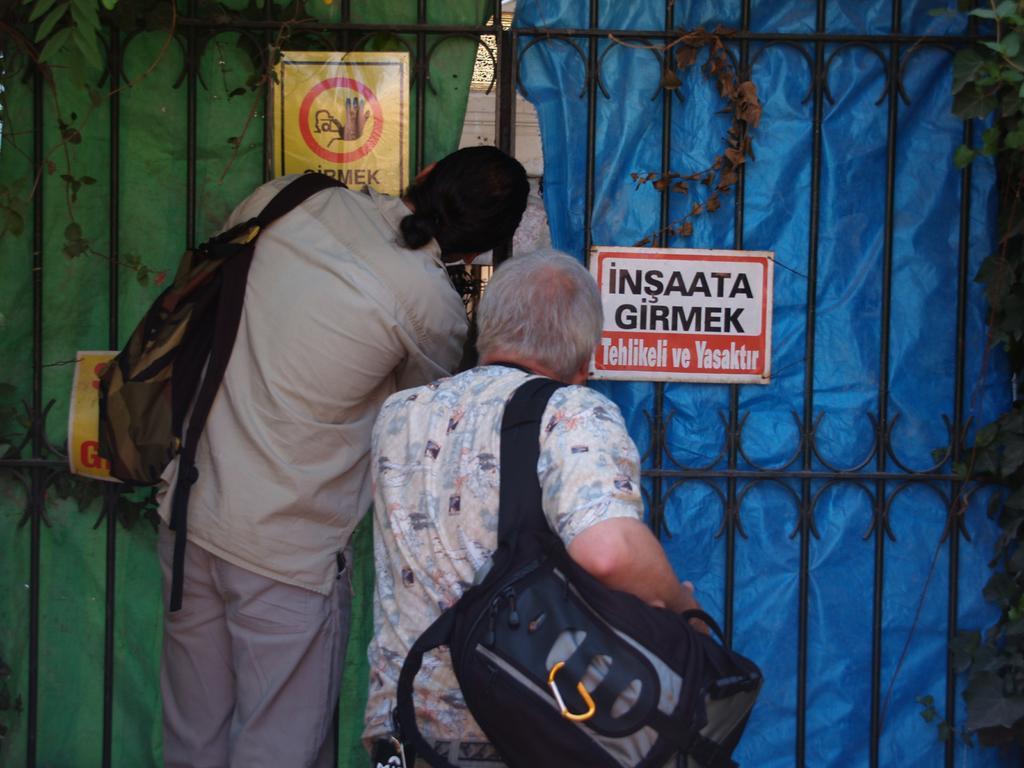Describe this image in one or two sentences. In this image in the front there are persons wearing a bag and standing and looking inside the gate. In the center there is a gate which is black in colour and behind the gate there are curtains which are blue and green in colour and on the right side in front of the gate there are leaves and on the gate there are boards with some text written on it. 